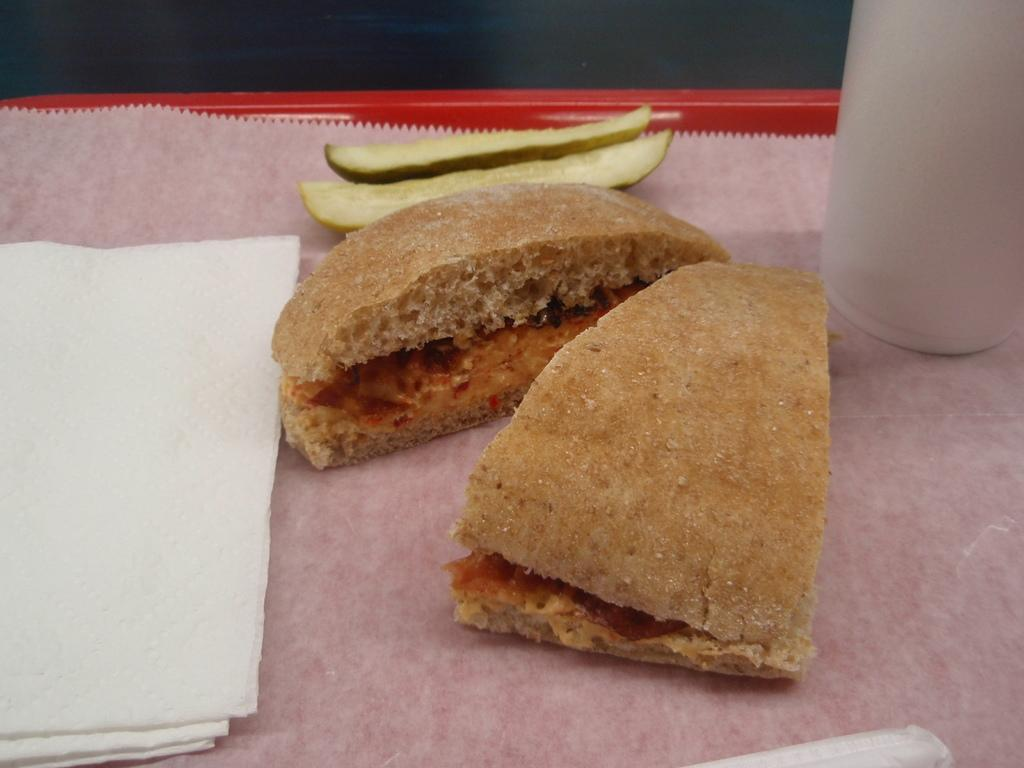What object is present in the image that can hold items? There is a tray in the image that can hold items. What type of food item is on the tray? There is a food item on the tray. What else is on the tray besides the food item? There are tissues and a glass on the tray. What event is taking place in the image? There is no event taking place in the image; it simply shows a tray with items on it. How does the glass adjust its position on the tray? The glass does not adjust its position on the tray in the image; it is stationary. 